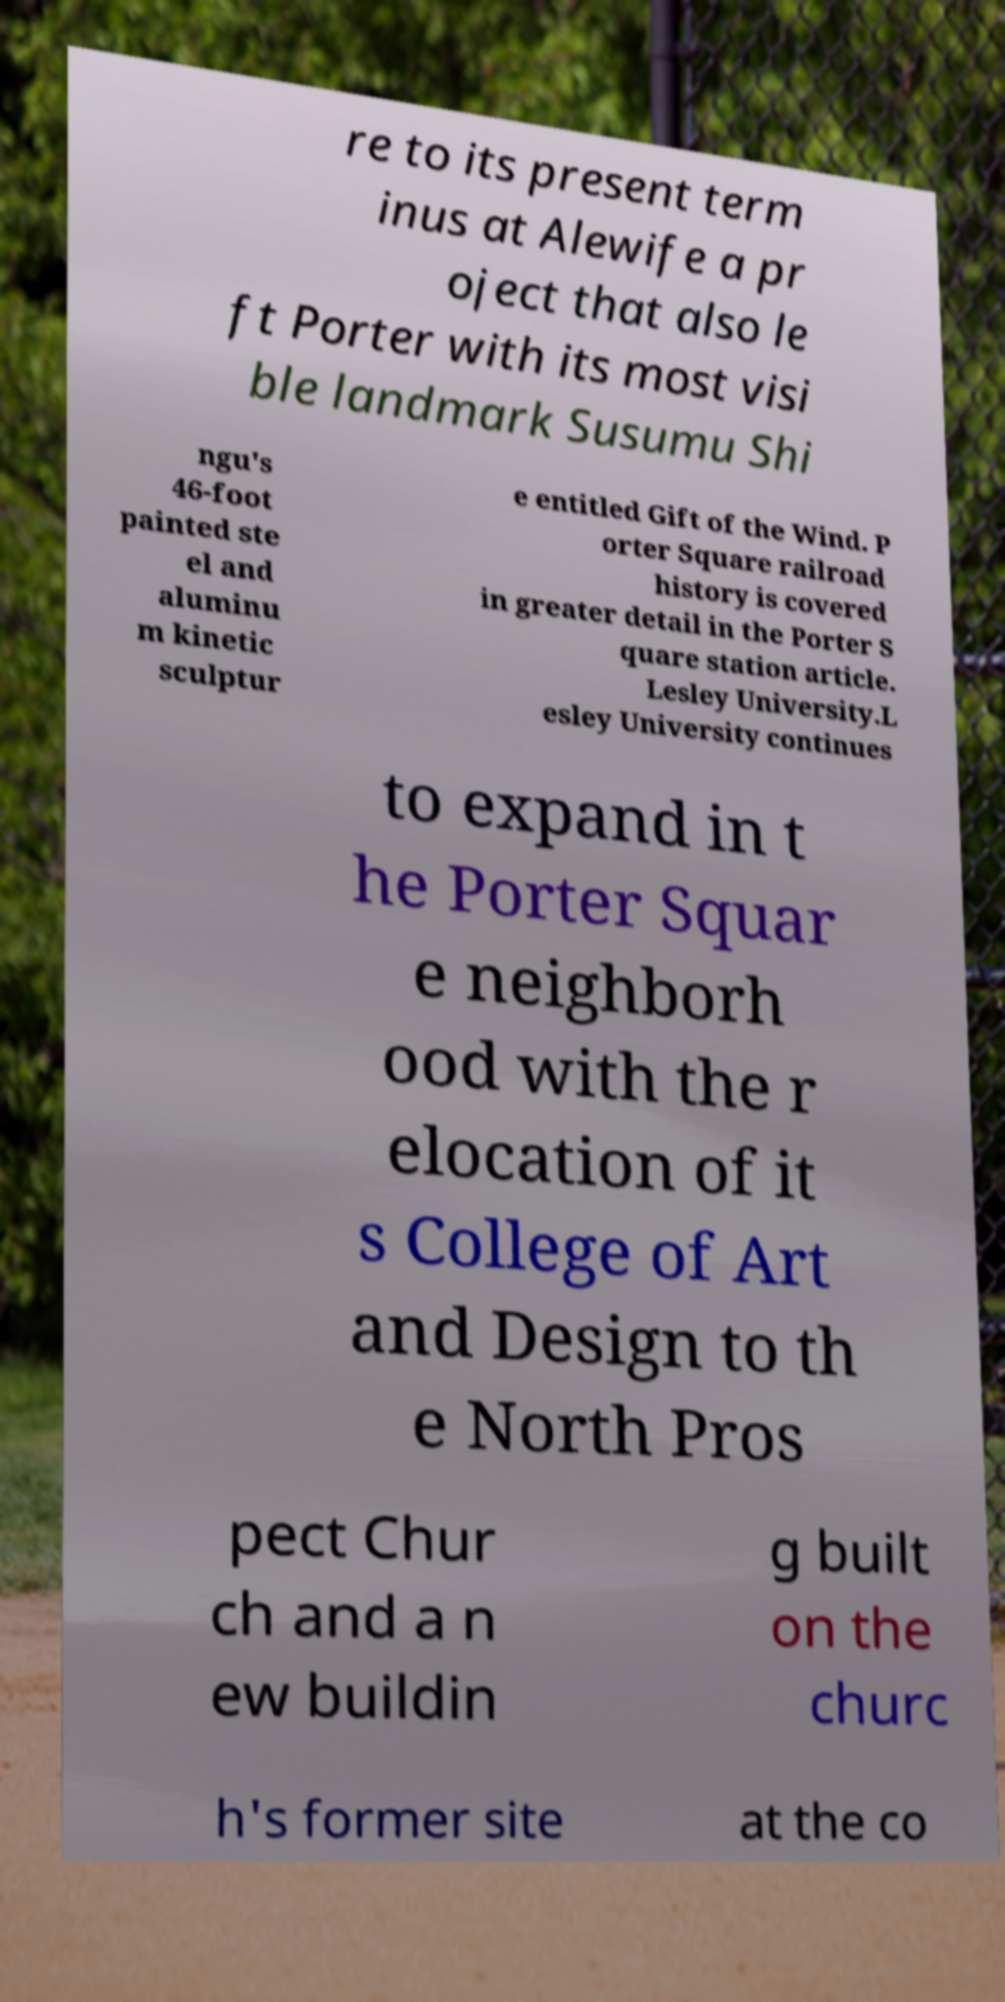Please identify and transcribe the text found in this image. re to its present term inus at Alewife a pr oject that also le ft Porter with its most visi ble landmark Susumu Shi ngu's 46-foot painted ste el and aluminu m kinetic sculptur e entitled Gift of the Wind. P orter Square railroad history is covered in greater detail in the Porter S quare station article. Lesley University.L esley University continues to expand in t he Porter Squar e neighborh ood with the r elocation of it s College of Art and Design to th e North Pros pect Chur ch and a n ew buildin g built on the churc h's former site at the co 